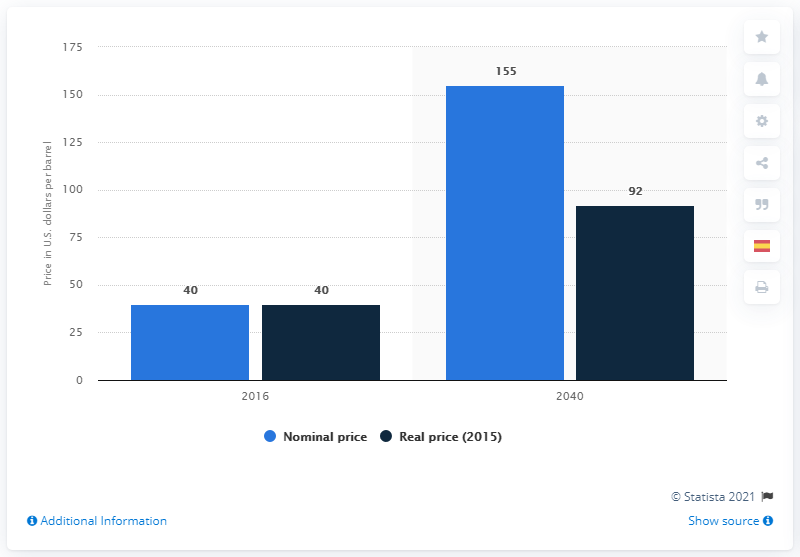Identify some key points in this picture. The nominal price of OPEC reference basket oil is expected to reach a value of 155 in 2040. The OPEC reference basket is expected to reach a price of 155 U.S. dollars in the year 2040. 